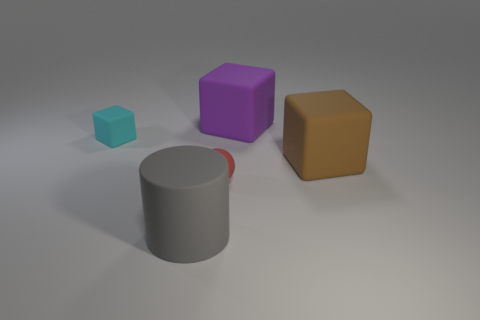What number of other objects are there of the same color as the small matte ball?
Your answer should be compact. 0. How many things are either large matte objects or red spheres?
Offer a terse response. 4. What is the color of the large block that is on the left side of the brown matte object?
Provide a short and direct response. Purple. Are there fewer big cubes that are in front of the purple block than large red matte cubes?
Give a very brief answer. No. Do the purple block and the red thing have the same material?
Make the answer very short. Yes. What number of things are either large cubes in front of the cyan rubber object or small matte things left of the large cylinder?
Make the answer very short. 2. Is there a purple matte block that has the same size as the brown thing?
Ensure brevity in your answer.  Yes. What is the color of the other small matte thing that is the same shape as the brown object?
Your answer should be compact. Cyan. There is a big matte block that is in front of the small cyan rubber cube; is there a big purple matte thing in front of it?
Give a very brief answer. No. Does the object that is behind the small cyan matte cube have the same shape as the small red matte thing?
Offer a very short reply. No. 